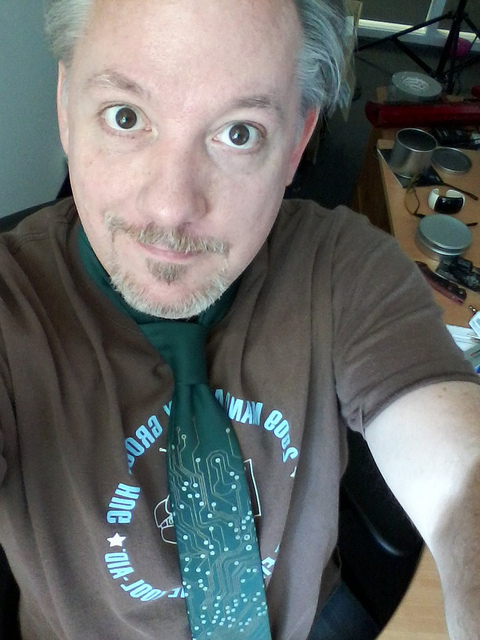<image>Why is he smiling? It is ambiguous why he is smiling. It could be because he is happy or for a picture. What is on the chair? It is unknown what is on the chair. But it can be seen that there is a man or a person. Why is he smiling? I am not sure why he is smiling. It can be because he is happy, taking a selfie, or because of his funny tie. What is on the chair? I don't know what is on the chair. It can be a man, a person, tape, or leather. 